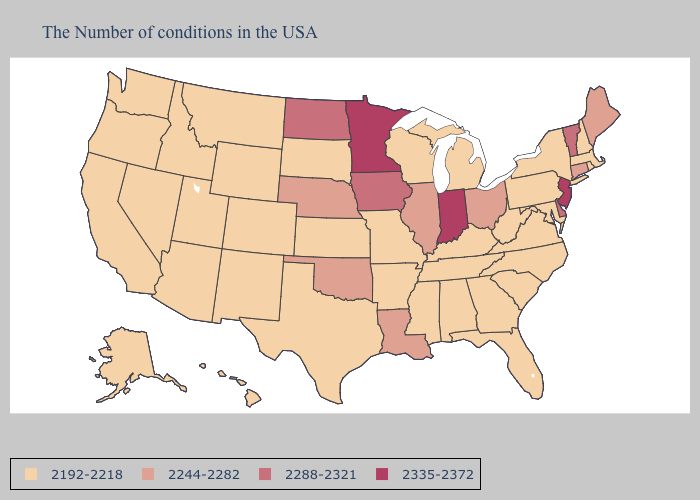What is the value of North Dakota?
Keep it brief. 2288-2321. What is the lowest value in the Northeast?
Give a very brief answer. 2192-2218. Does the map have missing data?
Be succinct. No. Which states hav the highest value in the MidWest?
Keep it brief. Indiana, Minnesota. What is the lowest value in states that border Missouri?
Quick response, please. 2192-2218. What is the value of Indiana?
Write a very short answer. 2335-2372. Name the states that have a value in the range 2288-2321?
Keep it brief. Vermont, Delaware, Iowa, North Dakota. What is the value of Utah?
Be succinct. 2192-2218. Does Michigan have the lowest value in the USA?
Write a very short answer. Yes. What is the value of Arkansas?
Short answer required. 2192-2218. Name the states that have a value in the range 2244-2282?
Write a very short answer. Maine, Connecticut, Ohio, Illinois, Louisiana, Nebraska, Oklahoma. What is the value of Hawaii?
Answer briefly. 2192-2218. Among the states that border Ohio , which have the highest value?
Concise answer only. Indiana. 